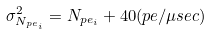<formula> <loc_0><loc_0><loc_500><loc_500>\sigma ^ { 2 } _ { N _ { p e _ { i } } } = N _ { p e _ { i } } + 4 0 ( p e / \mu s e c )</formula> 